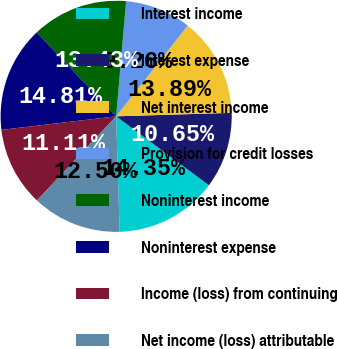Convert chart to OTSL. <chart><loc_0><loc_0><loc_500><loc_500><pie_chart><fcel>Interest income<fcel>Interest expense<fcel>Net interest income<fcel>Provision for credit losses<fcel>Noninterest income<fcel>Noninterest expense<fcel>Income (loss) from continuing<fcel>Net income (loss) attributable<nl><fcel>14.35%<fcel>10.65%<fcel>13.89%<fcel>9.26%<fcel>13.43%<fcel>14.81%<fcel>11.11%<fcel>12.5%<nl></chart> 